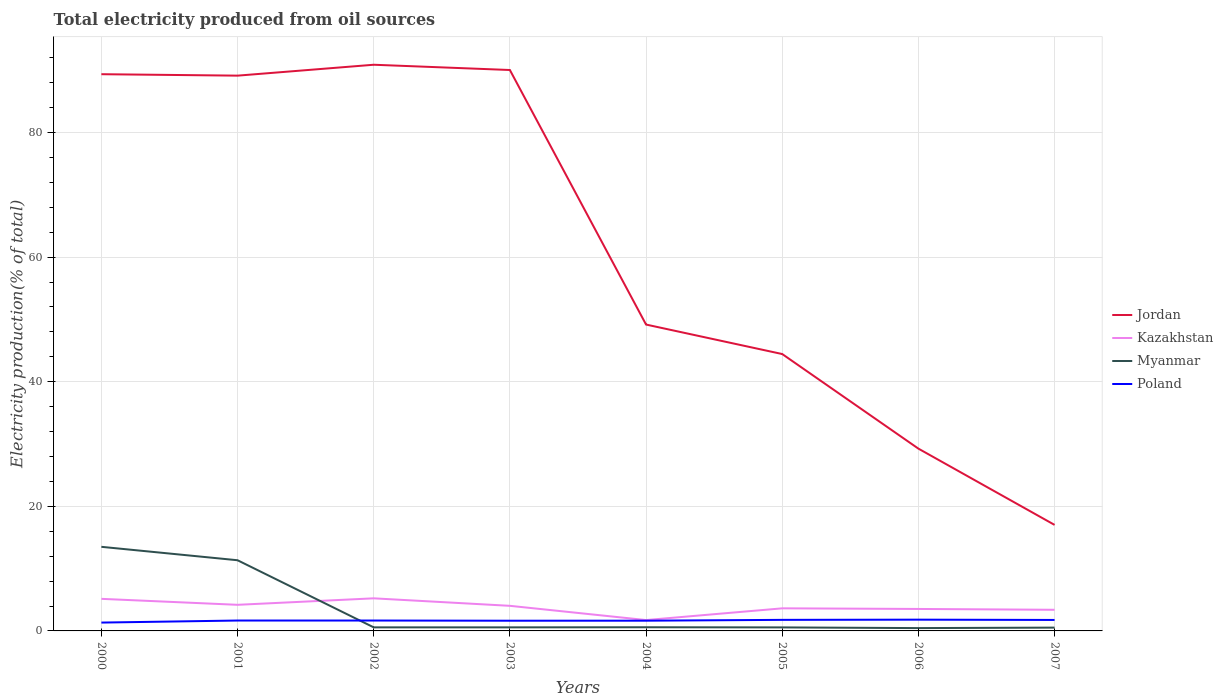Across all years, what is the maximum total electricity produced in Poland?
Provide a succinct answer. 1.34. In which year was the total electricity produced in Myanmar maximum?
Make the answer very short. 2006. What is the total total electricity produced in Kazakhstan in the graph?
Provide a short and direct response. 0.16. What is the difference between the highest and the second highest total electricity produced in Jordan?
Provide a short and direct response. 73.87. How many lines are there?
Offer a very short reply. 4. How many years are there in the graph?
Keep it short and to the point. 8. Does the graph contain any zero values?
Provide a short and direct response. No. Does the graph contain grids?
Give a very brief answer. Yes. How are the legend labels stacked?
Your response must be concise. Vertical. What is the title of the graph?
Offer a terse response. Total electricity produced from oil sources. What is the label or title of the X-axis?
Offer a very short reply. Years. What is the label or title of the Y-axis?
Offer a very short reply. Electricity production(% of total). What is the Electricity production(% of total) of Jordan in 2000?
Keep it short and to the point. 89.37. What is the Electricity production(% of total) of Kazakhstan in 2000?
Offer a very short reply. 5.15. What is the Electricity production(% of total) in Myanmar in 2000?
Offer a very short reply. 13.5. What is the Electricity production(% of total) in Poland in 2000?
Make the answer very short. 1.34. What is the Electricity production(% of total) of Jordan in 2001?
Your answer should be very brief. 89.14. What is the Electricity production(% of total) of Kazakhstan in 2001?
Provide a short and direct response. 4.19. What is the Electricity production(% of total) of Myanmar in 2001?
Offer a very short reply. 11.35. What is the Electricity production(% of total) of Poland in 2001?
Offer a terse response. 1.67. What is the Electricity production(% of total) in Jordan in 2002?
Make the answer very short. 90.89. What is the Electricity production(% of total) in Kazakhstan in 2002?
Keep it short and to the point. 5.23. What is the Electricity production(% of total) of Myanmar in 2002?
Offer a very short reply. 0.57. What is the Electricity production(% of total) in Poland in 2002?
Make the answer very short. 1.67. What is the Electricity production(% of total) of Jordan in 2003?
Your answer should be compact. 90.04. What is the Electricity production(% of total) in Kazakhstan in 2003?
Provide a succinct answer. 4.03. What is the Electricity production(% of total) in Myanmar in 2003?
Your response must be concise. 0.57. What is the Electricity production(% of total) of Poland in 2003?
Ensure brevity in your answer.  1.64. What is the Electricity production(% of total) of Jordan in 2004?
Offer a very short reply. 49.18. What is the Electricity production(% of total) in Kazakhstan in 2004?
Keep it short and to the point. 1.74. What is the Electricity production(% of total) in Myanmar in 2004?
Your response must be concise. 0.59. What is the Electricity production(% of total) of Poland in 2004?
Provide a succinct answer. 1.64. What is the Electricity production(% of total) of Jordan in 2005?
Your answer should be compact. 44.45. What is the Electricity production(% of total) of Kazakhstan in 2005?
Make the answer very short. 3.63. What is the Electricity production(% of total) of Myanmar in 2005?
Ensure brevity in your answer.  0.57. What is the Electricity production(% of total) in Poland in 2005?
Offer a very short reply. 1.77. What is the Electricity production(% of total) in Jordan in 2006?
Provide a short and direct response. 29.26. What is the Electricity production(% of total) of Kazakhstan in 2006?
Your response must be concise. 3.53. What is the Electricity production(% of total) in Myanmar in 2006?
Provide a succinct answer. 0.45. What is the Electricity production(% of total) in Poland in 2006?
Offer a terse response. 1.81. What is the Electricity production(% of total) of Jordan in 2007?
Give a very brief answer. 17.02. What is the Electricity production(% of total) of Kazakhstan in 2007?
Offer a terse response. 3.39. What is the Electricity production(% of total) in Myanmar in 2007?
Keep it short and to the point. 0.53. What is the Electricity production(% of total) in Poland in 2007?
Provide a succinct answer. 1.76. Across all years, what is the maximum Electricity production(% of total) in Jordan?
Your answer should be compact. 90.89. Across all years, what is the maximum Electricity production(% of total) in Kazakhstan?
Keep it short and to the point. 5.23. Across all years, what is the maximum Electricity production(% of total) of Myanmar?
Offer a very short reply. 13.5. Across all years, what is the maximum Electricity production(% of total) of Poland?
Ensure brevity in your answer.  1.81. Across all years, what is the minimum Electricity production(% of total) of Jordan?
Your answer should be very brief. 17.02. Across all years, what is the minimum Electricity production(% of total) of Kazakhstan?
Offer a terse response. 1.74. Across all years, what is the minimum Electricity production(% of total) of Myanmar?
Offer a terse response. 0.45. Across all years, what is the minimum Electricity production(% of total) in Poland?
Provide a succinct answer. 1.34. What is the total Electricity production(% of total) in Jordan in the graph?
Make the answer very short. 499.35. What is the total Electricity production(% of total) in Kazakhstan in the graph?
Give a very brief answer. 30.89. What is the total Electricity production(% of total) of Myanmar in the graph?
Your answer should be very brief. 28.13. What is the total Electricity production(% of total) in Poland in the graph?
Offer a terse response. 13.3. What is the difference between the Electricity production(% of total) in Jordan in 2000 and that in 2001?
Provide a short and direct response. 0.23. What is the difference between the Electricity production(% of total) of Kazakhstan in 2000 and that in 2001?
Make the answer very short. 0.96. What is the difference between the Electricity production(% of total) in Myanmar in 2000 and that in 2001?
Offer a very short reply. 2.16. What is the difference between the Electricity production(% of total) in Poland in 2000 and that in 2001?
Your answer should be very brief. -0.33. What is the difference between the Electricity production(% of total) in Jordan in 2000 and that in 2002?
Offer a terse response. -1.52. What is the difference between the Electricity production(% of total) in Kazakhstan in 2000 and that in 2002?
Ensure brevity in your answer.  -0.08. What is the difference between the Electricity production(% of total) in Myanmar in 2000 and that in 2002?
Give a very brief answer. 12.93. What is the difference between the Electricity production(% of total) of Poland in 2000 and that in 2002?
Ensure brevity in your answer.  -0.33. What is the difference between the Electricity production(% of total) of Jordan in 2000 and that in 2003?
Offer a very short reply. -0.67. What is the difference between the Electricity production(% of total) in Kazakhstan in 2000 and that in 2003?
Ensure brevity in your answer.  1.12. What is the difference between the Electricity production(% of total) of Myanmar in 2000 and that in 2003?
Provide a short and direct response. 12.93. What is the difference between the Electricity production(% of total) of Poland in 2000 and that in 2003?
Your answer should be compact. -0.3. What is the difference between the Electricity production(% of total) in Jordan in 2000 and that in 2004?
Make the answer very short. 40.19. What is the difference between the Electricity production(% of total) in Kazakhstan in 2000 and that in 2004?
Make the answer very short. 3.41. What is the difference between the Electricity production(% of total) of Myanmar in 2000 and that in 2004?
Make the answer very short. 12.91. What is the difference between the Electricity production(% of total) in Poland in 2000 and that in 2004?
Provide a short and direct response. -0.31. What is the difference between the Electricity production(% of total) in Jordan in 2000 and that in 2005?
Ensure brevity in your answer.  44.92. What is the difference between the Electricity production(% of total) in Kazakhstan in 2000 and that in 2005?
Your response must be concise. 1.52. What is the difference between the Electricity production(% of total) of Myanmar in 2000 and that in 2005?
Give a very brief answer. 12.94. What is the difference between the Electricity production(% of total) of Poland in 2000 and that in 2005?
Offer a terse response. -0.44. What is the difference between the Electricity production(% of total) in Jordan in 2000 and that in 2006?
Give a very brief answer. 60.11. What is the difference between the Electricity production(% of total) of Kazakhstan in 2000 and that in 2006?
Ensure brevity in your answer.  1.62. What is the difference between the Electricity production(% of total) of Myanmar in 2000 and that in 2006?
Your response must be concise. 13.05. What is the difference between the Electricity production(% of total) of Poland in 2000 and that in 2006?
Ensure brevity in your answer.  -0.47. What is the difference between the Electricity production(% of total) in Jordan in 2000 and that in 2007?
Keep it short and to the point. 72.35. What is the difference between the Electricity production(% of total) in Kazakhstan in 2000 and that in 2007?
Ensure brevity in your answer.  1.76. What is the difference between the Electricity production(% of total) of Myanmar in 2000 and that in 2007?
Your answer should be compact. 12.97. What is the difference between the Electricity production(% of total) in Poland in 2000 and that in 2007?
Give a very brief answer. -0.42. What is the difference between the Electricity production(% of total) of Jordan in 2001 and that in 2002?
Offer a very short reply. -1.75. What is the difference between the Electricity production(% of total) in Kazakhstan in 2001 and that in 2002?
Provide a short and direct response. -1.04. What is the difference between the Electricity production(% of total) of Myanmar in 2001 and that in 2002?
Offer a very short reply. 10.77. What is the difference between the Electricity production(% of total) of Poland in 2001 and that in 2002?
Your answer should be compact. 0. What is the difference between the Electricity production(% of total) in Jordan in 2001 and that in 2003?
Make the answer very short. -0.9. What is the difference between the Electricity production(% of total) of Kazakhstan in 2001 and that in 2003?
Your answer should be compact. 0.16. What is the difference between the Electricity production(% of total) in Myanmar in 2001 and that in 2003?
Offer a very short reply. 10.77. What is the difference between the Electricity production(% of total) of Poland in 2001 and that in 2003?
Keep it short and to the point. 0.03. What is the difference between the Electricity production(% of total) in Jordan in 2001 and that in 2004?
Offer a very short reply. 39.96. What is the difference between the Electricity production(% of total) of Kazakhstan in 2001 and that in 2004?
Provide a succinct answer. 2.45. What is the difference between the Electricity production(% of total) in Myanmar in 2001 and that in 2004?
Your answer should be very brief. 10.76. What is the difference between the Electricity production(% of total) of Poland in 2001 and that in 2004?
Your answer should be compact. 0.03. What is the difference between the Electricity production(% of total) of Jordan in 2001 and that in 2005?
Make the answer very short. 44.69. What is the difference between the Electricity production(% of total) of Kazakhstan in 2001 and that in 2005?
Keep it short and to the point. 0.57. What is the difference between the Electricity production(% of total) in Myanmar in 2001 and that in 2005?
Your answer should be very brief. 10.78. What is the difference between the Electricity production(% of total) in Poland in 2001 and that in 2005?
Make the answer very short. -0.11. What is the difference between the Electricity production(% of total) of Jordan in 2001 and that in 2006?
Ensure brevity in your answer.  59.88. What is the difference between the Electricity production(% of total) in Kazakhstan in 2001 and that in 2006?
Provide a succinct answer. 0.66. What is the difference between the Electricity production(% of total) in Myanmar in 2001 and that in 2006?
Offer a very short reply. 10.89. What is the difference between the Electricity production(% of total) in Poland in 2001 and that in 2006?
Ensure brevity in your answer.  -0.14. What is the difference between the Electricity production(% of total) of Jordan in 2001 and that in 2007?
Your answer should be very brief. 72.12. What is the difference between the Electricity production(% of total) of Kazakhstan in 2001 and that in 2007?
Provide a succinct answer. 0.8. What is the difference between the Electricity production(% of total) in Myanmar in 2001 and that in 2007?
Provide a short and direct response. 10.81. What is the difference between the Electricity production(% of total) of Poland in 2001 and that in 2007?
Provide a succinct answer. -0.09. What is the difference between the Electricity production(% of total) in Jordan in 2002 and that in 2003?
Give a very brief answer. 0.85. What is the difference between the Electricity production(% of total) in Kazakhstan in 2002 and that in 2003?
Make the answer very short. 1.2. What is the difference between the Electricity production(% of total) of Myanmar in 2002 and that in 2003?
Give a very brief answer. 0. What is the difference between the Electricity production(% of total) in Poland in 2002 and that in 2003?
Your answer should be very brief. 0.03. What is the difference between the Electricity production(% of total) in Jordan in 2002 and that in 2004?
Ensure brevity in your answer.  41.71. What is the difference between the Electricity production(% of total) in Kazakhstan in 2002 and that in 2004?
Ensure brevity in your answer.  3.49. What is the difference between the Electricity production(% of total) of Myanmar in 2002 and that in 2004?
Keep it short and to the point. -0.02. What is the difference between the Electricity production(% of total) in Poland in 2002 and that in 2004?
Your response must be concise. 0.02. What is the difference between the Electricity production(% of total) of Jordan in 2002 and that in 2005?
Your answer should be compact. 46.44. What is the difference between the Electricity production(% of total) in Kazakhstan in 2002 and that in 2005?
Make the answer very short. 1.61. What is the difference between the Electricity production(% of total) of Myanmar in 2002 and that in 2005?
Your response must be concise. 0.01. What is the difference between the Electricity production(% of total) in Poland in 2002 and that in 2005?
Ensure brevity in your answer.  -0.11. What is the difference between the Electricity production(% of total) in Jordan in 2002 and that in 2006?
Your response must be concise. 61.63. What is the difference between the Electricity production(% of total) in Kazakhstan in 2002 and that in 2006?
Offer a very short reply. 1.71. What is the difference between the Electricity production(% of total) of Myanmar in 2002 and that in 2006?
Offer a very short reply. 0.12. What is the difference between the Electricity production(% of total) in Poland in 2002 and that in 2006?
Keep it short and to the point. -0.14. What is the difference between the Electricity production(% of total) in Jordan in 2002 and that in 2007?
Give a very brief answer. 73.87. What is the difference between the Electricity production(% of total) of Kazakhstan in 2002 and that in 2007?
Your response must be concise. 1.84. What is the difference between the Electricity production(% of total) of Myanmar in 2002 and that in 2007?
Give a very brief answer. 0.04. What is the difference between the Electricity production(% of total) in Poland in 2002 and that in 2007?
Provide a short and direct response. -0.09. What is the difference between the Electricity production(% of total) of Jordan in 2003 and that in 2004?
Keep it short and to the point. 40.86. What is the difference between the Electricity production(% of total) of Kazakhstan in 2003 and that in 2004?
Your response must be concise. 2.29. What is the difference between the Electricity production(% of total) of Myanmar in 2003 and that in 2004?
Your answer should be compact. -0.02. What is the difference between the Electricity production(% of total) of Poland in 2003 and that in 2004?
Keep it short and to the point. -0.01. What is the difference between the Electricity production(% of total) of Jordan in 2003 and that in 2005?
Provide a succinct answer. 45.59. What is the difference between the Electricity production(% of total) in Kazakhstan in 2003 and that in 2005?
Your response must be concise. 0.4. What is the difference between the Electricity production(% of total) of Myanmar in 2003 and that in 2005?
Your answer should be compact. 0.01. What is the difference between the Electricity production(% of total) of Poland in 2003 and that in 2005?
Make the answer very short. -0.14. What is the difference between the Electricity production(% of total) of Jordan in 2003 and that in 2006?
Ensure brevity in your answer.  60.78. What is the difference between the Electricity production(% of total) of Kazakhstan in 2003 and that in 2006?
Keep it short and to the point. 0.5. What is the difference between the Electricity production(% of total) in Myanmar in 2003 and that in 2006?
Make the answer very short. 0.12. What is the difference between the Electricity production(% of total) in Poland in 2003 and that in 2006?
Your response must be concise. -0.17. What is the difference between the Electricity production(% of total) in Jordan in 2003 and that in 2007?
Make the answer very short. 73.02. What is the difference between the Electricity production(% of total) in Kazakhstan in 2003 and that in 2007?
Provide a short and direct response. 0.63. What is the difference between the Electricity production(% of total) in Myanmar in 2003 and that in 2007?
Your answer should be compact. 0.04. What is the difference between the Electricity production(% of total) in Poland in 2003 and that in 2007?
Offer a terse response. -0.12. What is the difference between the Electricity production(% of total) of Jordan in 2004 and that in 2005?
Provide a succinct answer. 4.73. What is the difference between the Electricity production(% of total) of Kazakhstan in 2004 and that in 2005?
Provide a short and direct response. -1.88. What is the difference between the Electricity production(% of total) in Myanmar in 2004 and that in 2005?
Your answer should be very brief. 0.02. What is the difference between the Electricity production(% of total) of Poland in 2004 and that in 2005?
Make the answer very short. -0.13. What is the difference between the Electricity production(% of total) in Jordan in 2004 and that in 2006?
Offer a terse response. 19.92. What is the difference between the Electricity production(% of total) of Kazakhstan in 2004 and that in 2006?
Provide a short and direct response. -1.78. What is the difference between the Electricity production(% of total) of Myanmar in 2004 and that in 2006?
Your response must be concise. 0.13. What is the difference between the Electricity production(% of total) of Poland in 2004 and that in 2006?
Your response must be concise. -0.17. What is the difference between the Electricity production(% of total) in Jordan in 2004 and that in 2007?
Your answer should be very brief. 32.16. What is the difference between the Electricity production(% of total) in Kazakhstan in 2004 and that in 2007?
Offer a terse response. -1.65. What is the difference between the Electricity production(% of total) in Myanmar in 2004 and that in 2007?
Your answer should be very brief. 0.06. What is the difference between the Electricity production(% of total) in Poland in 2004 and that in 2007?
Offer a terse response. -0.12. What is the difference between the Electricity production(% of total) of Jordan in 2005 and that in 2006?
Keep it short and to the point. 15.19. What is the difference between the Electricity production(% of total) in Kazakhstan in 2005 and that in 2006?
Your response must be concise. 0.1. What is the difference between the Electricity production(% of total) in Myanmar in 2005 and that in 2006?
Ensure brevity in your answer.  0.11. What is the difference between the Electricity production(% of total) in Poland in 2005 and that in 2006?
Provide a short and direct response. -0.03. What is the difference between the Electricity production(% of total) in Jordan in 2005 and that in 2007?
Your answer should be very brief. 27.43. What is the difference between the Electricity production(% of total) of Kazakhstan in 2005 and that in 2007?
Make the answer very short. 0.23. What is the difference between the Electricity production(% of total) of Myanmar in 2005 and that in 2007?
Offer a terse response. 0.03. What is the difference between the Electricity production(% of total) in Poland in 2005 and that in 2007?
Make the answer very short. 0.01. What is the difference between the Electricity production(% of total) in Jordan in 2006 and that in 2007?
Give a very brief answer. 12.24. What is the difference between the Electricity production(% of total) in Kazakhstan in 2006 and that in 2007?
Your response must be concise. 0.13. What is the difference between the Electricity production(% of total) in Myanmar in 2006 and that in 2007?
Your answer should be compact. -0.08. What is the difference between the Electricity production(% of total) in Poland in 2006 and that in 2007?
Provide a succinct answer. 0.05. What is the difference between the Electricity production(% of total) in Jordan in 2000 and the Electricity production(% of total) in Kazakhstan in 2001?
Your response must be concise. 85.18. What is the difference between the Electricity production(% of total) of Jordan in 2000 and the Electricity production(% of total) of Myanmar in 2001?
Give a very brief answer. 78.02. What is the difference between the Electricity production(% of total) in Jordan in 2000 and the Electricity production(% of total) in Poland in 2001?
Your answer should be very brief. 87.7. What is the difference between the Electricity production(% of total) in Kazakhstan in 2000 and the Electricity production(% of total) in Myanmar in 2001?
Provide a succinct answer. -6.2. What is the difference between the Electricity production(% of total) of Kazakhstan in 2000 and the Electricity production(% of total) of Poland in 2001?
Offer a very short reply. 3.48. What is the difference between the Electricity production(% of total) of Myanmar in 2000 and the Electricity production(% of total) of Poland in 2001?
Provide a succinct answer. 11.83. What is the difference between the Electricity production(% of total) in Jordan in 2000 and the Electricity production(% of total) in Kazakhstan in 2002?
Your response must be concise. 84.14. What is the difference between the Electricity production(% of total) in Jordan in 2000 and the Electricity production(% of total) in Myanmar in 2002?
Offer a very short reply. 88.8. What is the difference between the Electricity production(% of total) in Jordan in 2000 and the Electricity production(% of total) in Poland in 2002?
Provide a succinct answer. 87.7. What is the difference between the Electricity production(% of total) of Kazakhstan in 2000 and the Electricity production(% of total) of Myanmar in 2002?
Offer a very short reply. 4.58. What is the difference between the Electricity production(% of total) of Kazakhstan in 2000 and the Electricity production(% of total) of Poland in 2002?
Make the answer very short. 3.48. What is the difference between the Electricity production(% of total) in Myanmar in 2000 and the Electricity production(% of total) in Poland in 2002?
Keep it short and to the point. 11.83. What is the difference between the Electricity production(% of total) in Jordan in 2000 and the Electricity production(% of total) in Kazakhstan in 2003?
Make the answer very short. 85.34. What is the difference between the Electricity production(% of total) of Jordan in 2000 and the Electricity production(% of total) of Myanmar in 2003?
Keep it short and to the point. 88.8. What is the difference between the Electricity production(% of total) in Jordan in 2000 and the Electricity production(% of total) in Poland in 2003?
Make the answer very short. 87.73. What is the difference between the Electricity production(% of total) of Kazakhstan in 2000 and the Electricity production(% of total) of Myanmar in 2003?
Offer a terse response. 4.58. What is the difference between the Electricity production(% of total) in Kazakhstan in 2000 and the Electricity production(% of total) in Poland in 2003?
Keep it short and to the point. 3.51. What is the difference between the Electricity production(% of total) in Myanmar in 2000 and the Electricity production(% of total) in Poland in 2003?
Your answer should be compact. 11.86. What is the difference between the Electricity production(% of total) of Jordan in 2000 and the Electricity production(% of total) of Kazakhstan in 2004?
Ensure brevity in your answer.  87.63. What is the difference between the Electricity production(% of total) of Jordan in 2000 and the Electricity production(% of total) of Myanmar in 2004?
Ensure brevity in your answer.  88.78. What is the difference between the Electricity production(% of total) of Jordan in 2000 and the Electricity production(% of total) of Poland in 2004?
Provide a short and direct response. 87.73. What is the difference between the Electricity production(% of total) of Kazakhstan in 2000 and the Electricity production(% of total) of Myanmar in 2004?
Make the answer very short. 4.56. What is the difference between the Electricity production(% of total) of Kazakhstan in 2000 and the Electricity production(% of total) of Poland in 2004?
Give a very brief answer. 3.51. What is the difference between the Electricity production(% of total) of Myanmar in 2000 and the Electricity production(% of total) of Poland in 2004?
Provide a short and direct response. 11.86. What is the difference between the Electricity production(% of total) in Jordan in 2000 and the Electricity production(% of total) in Kazakhstan in 2005?
Give a very brief answer. 85.74. What is the difference between the Electricity production(% of total) in Jordan in 2000 and the Electricity production(% of total) in Myanmar in 2005?
Your answer should be very brief. 88.8. What is the difference between the Electricity production(% of total) in Jordan in 2000 and the Electricity production(% of total) in Poland in 2005?
Your answer should be compact. 87.59. What is the difference between the Electricity production(% of total) of Kazakhstan in 2000 and the Electricity production(% of total) of Myanmar in 2005?
Make the answer very short. 4.58. What is the difference between the Electricity production(% of total) of Kazakhstan in 2000 and the Electricity production(% of total) of Poland in 2005?
Ensure brevity in your answer.  3.38. What is the difference between the Electricity production(% of total) of Myanmar in 2000 and the Electricity production(% of total) of Poland in 2005?
Make the answer very short. 11.73. What is the difference between the Electricity production(% of total) in Jordan in 2000 and the Electricity production(% of total) in Kazakhstan in 2006?
Your answer should be very brief. 85.84. What is the difference between the Electricity production(% of total) in Jordan in 2000 and the Electricity production(% of total) in Myanmar in 2006?
Give a very brief answer. 88.92. What is the difference between the Electricity production(% of total) in Jordan in 2000 and the Electricity production(% of total) in Poland in 2006?
Your response must be concise. 87.56. What is the difference between the Electricity production(% of total) in Kazakhstan in 2000 and the Electricity production(% of total) in Myanmar in 2006?
Offer a very short reply. 4.7. What is the difference between the Electricity production(% of total) in Kazakhstan in 2000 and the Electricity production(% of total) in Poland in 2006?
Provide a succinct answer. 3.34. What is the difference between the Electricity production(% of total) in Myanmar in 2000 and the Electricity production(% of total) in Poland in 2006?
Ensure brevity in your answer.  11.69. What is the difference between the Electricity production(% of total) in Jordan in 2000 and the Electricity production(% of total) in Kazakhstan in 2007?
Provide a succinct answer. 85.98. What is the difference between the Electricity production(% of total) of Jordan in 2000 and the Electricity production(% of total) of Myanmar in 2007?
Ensure brevity in your answer.  88.84. What is the difference between the Electricity production(% of total) of Jordan in 2000 and the Electricity production(% of total) of Poland in 2007?
Provide a succinct answer. 87.61. What is the difference between the Electricity production(% of total) in Kazakhstan in 2000 and the Electricity production(% of total) in Myanmar in 2007?
Offer a very short reply. 4.62. What is the difference between the Electricity production(% of total) of Kazakhstan in 2000 and the Electricity production(% of total) of Poland in 2007?
Provide a short and direct response. 3.39. What is the difference between the Electricity production(% of total) of Myanmar in 2000 and the Electricity production(% of total) of Poland in 2007?
Provide a short and direct response. 11.74. What is the difference between the Electricity production(% of total) of Jordan in 2001 and the Electricity production(% of total) of Kazakhstan in 2002?
Keep it short and to the point. 83.9. What is the difference between the Electricity production(% of total) of Jordan in 2001 and the Electricity production(% of total) of Myanmar in 2002?
Give a very brief answer. 88.57. What is the difference between the Electricity production(% of total) of Jordan in 2001 and the Electricity production(% of total) of Poland in 2002?
Give a very brief answer. 87.47. What is the difference between the Electricity production(% of total) of Kazakhstan in 2001 and the Electricity production(% of total) of Myanmar in 2002?
Your answer should be compact. 3.62. What is the difference between the Electricity production(% of total) of Kazakhstan in 2001 and the Electricity production(% of total) of Poland in 2002?
Give a very brief answer. 2.52. What is the difference between the Electricity production(% of total) of Myanmar in 2001 and the Electricity production(% of total) of Poland in 2002?
Give a very brief answer. 9.68. What is the difference between the Electricity production(% of total) of Jordan in 2001 and the Electricity production(% of total) of Kazakhstan in 2003?
Give a very brief answer. 85.11. What is the difference between the Electricity production(% of total) in Jordan in 2001 and the Electricity production(% of total) in Myanmar in 2003?
Make the answer very short. 88.57. What is the difference between the Electricity production(% of total) of Jordan in 2001 and the Electricity production(% of total) of Poland in 2003?
Your answer should be compact. 87.5. What is the difference between the Electricity production(% of total) of Kazakhstan in 2001 and the Electricity production(% of total) of Myanmar in 2003?
Your answer should be very brief. 3.62. What is the difference between the Electricity production(% of total) in Kazakhstan in 2001 and the Electricity production(% of total) in Poland in 2003?
Provide a succinct answer. 2.55. What is the difference between the Electricity production(% of total) of Myanmar in 2001 and the Electricity production(% of total) of Poland in 2003?
Provide a short and direct response. 9.71. What is the difference between the Electricity production(% of total) in Jordan in 2001 and the Electricity production(% of total) in Kazakhstan in 2004?
Provide a succinct answer. 87.39. What is the difference between the Electricity production(% of total) of Jordan in 2001 and the Electricity production(% of total) of Myanmar in 2004?
Provide a succinct answer. 88.55. What is the difference between the Electricity production(% of total) in Jordan in 2001 and the Electricity production(% of total) in Poland in 2004?
Ensure brevity in your answer.  87.49. What is the difference between the Electricity production(% of total) of Kazakhstan in 2001 and the Electricity production(% of total) of Myanmar in 2004?
Provide a succinct answer. 3.6. What is the difference between the Electricity production(% of total) in Kazakhstan in 2001 and the Electricity production(% of total) in Poland in 2004?
Your answer should be very brief. 2.55. What is the difference between the Electricity production(% of total) in Myanmar in 2001 and the Electricity production(% of total) in Poland in 2004?
Offer a very short reply. 9.7. What is the difference between the Electricity production(% of total) of Jordan in 2001 and the Electricity production(% of total) of Kazakhstan in 2005?
Offer a terse response. 85.51. What is the difference between the Electricity production(% of total) of Jordan in 2001 and the Electricity production(% of total) of Myanmar in 2005?
Offer a terse response. 88.57. What is the difference between the Electricity production(% of total) of Jordan in 2001 and the Electricity production(% of total) of Poland in 2005?
Provide a succinct answer. 87.36. What is the difference between the Electricity production(% of total) in Kazakhstan in 2001 and the Electricity production(% of total) in Myanmar in 2005?
Offer a terse response. 3.63. What is the difference between the Electricity production(% of total) in Kazakhstan in 2001 and the Electricity production(% of total) in Poland in 2005?
Ensure brevity in your answer.  2.42. What is the difference between the Electricity production(% of total) of Myanmar in 2001 and the Electricity production(% of total) of Poland in 2005?
Make the answer very short. 9.57. What is the difference between the Electricity production(% of total) in Jordan in 2001 and the Electricity production(% of total) in Kazakhstan in 2006?
Ensure brevity in your answer.  85.61. What is the difference between the Electricity production(% of total) in Jordan in 2001 and the Electricity production(% of total) in Myanmar in 2006?
Give a very brief answer. 88.68. What is the difference between the Electricity production(% of total) in Jordan in 2001 and the Electricity production(% of total) in Poland in 2006?
Make the answer very short. 87.33. What is the difference between the Electricity production(% of total) of Kazakhstan in 2001 and the Electricity production(% of total) of Myanmar in 2006?
Provide a succinct answer. 3.74. What is the difference between the Electricity production(% of total) in Kazakhstan in 2001 and the Electricity production(% of total) in Poland in 2006?
Keep it short and to the point. 2.38. What is the difference between the Electricity production(% of total) in Myanmar in 2001 and the Electricity production(% of total) in Poland in 2006?
Your answer should be very brief. 9.54. What is the difference between the Electricity production(% of total) of Jordan in 2001 and the Electricity production(% of total) of Kazakhstan in 2007?
Your answer should be compact. 85.74. What is the difference between the Electricity production(% of total) in Jordan in 2001 and the Electricity production(% of total) in Myanmar in 2007?
Ensure brevity in your answer.  88.61. What is the difference between the Electricity production(% of total) of Jordan in 2001 and the Electricity production(% of total) of Poland in 2007?
Make the answer very short. 87.38. What is the difference between the Electricity production(% of total) in Kazakhstan in 2001 and the Electricity production(% of total) in Myanmar in 2007?
Offer a terse response. 3.66. What is the difference between the Electricity production(% of total) of Kazakhstan in 2001 and the Electricity production(% of total) of Poland in 2007?
Ensure brevity in your answer.  2.43. What is the difference between the Electricity production(% of total) of Myanmar in 2001 and the Electricity production(% of total) of Poland in 2007?
Offer a very short reply. 9.59. What is the difference between the Electricity production(% of total) in Jordan in 2002 and the Electricity production(% of total) in Kazakhstan in 2003?
Offer a terse response. 86.86. What is the difference between the Electricity production(% of total) in Jordan in 2002 and the Electricity production(% of total) in Myanmar in 2003?
Your answer should be compact. 90.32. What is the difference between the Electricity production(% of total) of Jordan in 2002 and the Electricity production(% of total) of Poland in 2003?
Your answer should be compact. 89.25. What is the difference between the Electricity production(% of total) of Kazakhstan in 2002 and the Electricity production(% of total) of Myanmar in 2003?
Offer a very short reply. 4.66. What is the difference between the Electricity production(% of total) in Kazakhstan in 2002 and the Electricity production(% of total) in Poland in 2003?
Ensure brevity in your answer.  3.6. What is the difference between the Electricity production(% of total) of Myanmar in 2002 and the Electricity production(% of total) of Poland in 2003?
Keep it short and to the point. -1.06. What is the difference between the Electricity production(% of total) in Jordan in 2002 and the Electricity production(% of total) in Kazakhstan in 2004?
Keep it short and to the point. 89.14. What is the difference between the Electricity production(% of total) in Jordan in 2002 and the Electricity production(% of total) in Myanmar in 2004?
Provide a short and direct response. 90.3. What is the difference between the Electricity production(% of total) of Jordan in 2002 and the Electricity production(% of total) of Poland in 2004?
Offer a terse response. 89.24. What is the difference between the Electricity production(% of total) of Kazakhstan in 2002 and the Electricity production(% of total) of Myanmar in 2004?
Make the answer very short. 4.64. What is the difference between the Electricity production(% of total) of Kazakhstan in 2002 and the Electricity production(% of total) of Poland in 2004?
Provide a short and direct response. 3.59. What is the difference between the Electricity production(% of total) of Myanmar in 2002 and the Electricity production(% of total) of Poland in 2004?
Provide a short and direct response. -1.07. What is the difference between the Electricity production(% of total) of Jordan in 2002 and the Electricity production(% of total) of Kazakhstan in 2005?
Your answer should be very brief. 87.26. What is the difference between the Electricity production(% of total) of Jordan in 2002 and the Electricity production(% of total) of Myanmar in 2005?
Make the answer very short. 90.32. What is the difference between the Electricity production(% of total) of Jordan in 2002 and the Electricity production(% of total) of Poland in 2005?
Make the answer very short. 89.11. What is the difference between the Electricity production(% of total) in Kazakhstan in 2002 and the Electricity production(% of total) in Myanmar in 2005?
Provide a succinct answer. 4.67. What is the difference between the Electricity production(% of total) in Kazakhstan in 2002 and the Electricity production(% of total) in Poland in 2005?
Ensure brevity in your answer.  3.46. What is the difference between the Electricity production(% of total) in Myanmar in 2002 and the Electricity production(% of total) in Poland in 2005?
Give a very brief answer. -1.2. What is the difference between the Electricity production(% of total) in Jordan in 2002 and the Electricity production(% of total) in Kazakhstan in 2006?
Provide a succinct answer. 87.36. What is the difference between the Electricity production(% of total) in Jordan in 2002 and the Electricity production(% of total) in Myanmar in 2006?
Make the answer very short. 90.43. What is the difference between the Electricity production(% of total) in Jordan in 2002 and the Electricity production(% of total) in Poland in 2006?
Offer a terse response. 89.08. What is the difference between the Electricity production(% of total) in Kazakhstan in 2002 and the Electricity production(% of total) in Myanmar in 2006?
Your answer should be very brief. 4.78. What is the difference between the Electricity production(% of total) in Kazakhstan in 2002 and the Electricity production(% of total) in Poland in 2006?
Give a very brief answer. 3.42. What is the difference between the Electricity production(% of total) of Myanmar in 2002 and the Electricity production(% of total) of Poland in 2006?
Provide a short and direct response. -1.24. What is the difference between the Electricity production(% of total) in Jordan in 2002 and the Electricity production(% of total) in Kazakhstan in 2007?
Your answer should be compact. 87.49. What is the difference between the Electricity production(% of total) in Jordan in 2002 and the Electricity production(% of total) in Myanmar in 2007?
Your answer should be compact. 90.36. What is the difference between the Electricity production(% of total) in Jordan in 2002 and the Electricity production(% of total) in Poland in 2007?
Provide a succinct answer. 89.13. What is the difference between the Electricity production(% of total) of Kazakhstan in 2002 and the Electricity production(% of total) of Myanmar in 2007?
Make the answer very short. 4.7. What is the difference between the Electricity production(% of total) of Kazakhstan in 2002 and the Electricity production(% of total) of Poland in 2007?
Provide a succinct answer. 3.47. What is the difference between the Electricity production(% of total) of Myanmar in 2002 and the Electricity production(% of total) of Poland in 2007?
Your answer should be very brief. -1.19. What is the difference between the Electricity production(% of total) in Jordan in 2003 and the Electricity production(% of total) in Kazakhstan in 2004?
Your answer should be very brief. 88.3. What is the difference between the Electricity production(% of total) in Jordan in 2003 and the Electricity production(% of total) in Myanmar in 2004?
Offer a very short reply. 89.45. What is the difference between the Electricity production(% of total) of Jordan in 2003 and the Electricity production(% of total) of Poland in 2004?
Your answer should be very brief. 88.4. What is the difference between the Electricity production(% of total) in Kazakhstan in 2003 and the Electricity production(% of total) in Myanmar in 2004?
Make the answer very short. 3.44. What is the difference between the Electricity production(% of total) of Kazakhstan in 2003 and the Electricity production(% of total) of Poland in 2004?
Keep it short and to the point. 2.39. What is the difference between the Electricity production(% of total) in Myanmar in 2003 and the Electricity production(% of total) in Poland in 2004?
Provide a succinct answer. -1.07. What is the difference between the Electricity production(% of total) of Jordan in 2003 and the Electricity production(% of total) of Kazakhstan in 2005?
Provide a succinct answer. 86.42. What is the difference between the Electricity production(% of total) of Jordan in 2003 and the Electricity production(% of total) of Myanmar in 2005?
Provide a succinct answer. 89.48. What is the difference between the Electricity production(% of total) in Jordan in 2003 and the Electricity production(% of total) in Poland in 2005?
Your answer should be compact. 88.27. What is the difference between the Electricity production(% of total) of Kazakhstan in 2003 and the Electricity production(% of total) of Myanmar in 2005?
Offer a very short reply. 3.46. What is the difference between the Electricity production(% of total) in Kazakhstan in 2003 and the Electricity production(% of total) in Poland in 2005?
Provide a short and direct response. 2.25. What is the difference between the Electricity production(% of total) in Myanmar in 2003 and the Electricity production(% of total) in Poland in 2005?
Keep it short and to the point. -1.2. What is the difference between the Electricity production(% of total) in Jordan in 2003 and the Electricity production(% of total) in Kazakhstan in 2006?
Your response must be concise. 86.52. What is the difference between the Electricity production(% of total) in Jordan in 2003 and the Electricity production(% of total) in Myanmar in 2006?
Your response must be concise. 89.59. What is the difference between the Electricity production(% of total) in Jordan in 2003 and the Electricity production(% of total) in Poland in 2006?
Keep it short and to the point. 88.23. What is the difference between the Electricity production(% of total) of Kazakhstan in 2003 and the Electricity production(% of total) of Myanmar in 2006?
Keep it short and to the point. 3.57. What is the difference between the Electricity production(% of total) in Kazakhstan in 2003 and the Electricity production(% of total) in Poland in 2006?
Offer a very short reply. 2.22. What is the difference between the Electricity production(% of total) of Myanmar in 2003 and the Electricity production(% of total) of Poland in 2006?
Ensure brevity in your answer.  -1.24. What is the difference between the Electricity production(% of total) of Jordan in 2003 and the Electricity production(% of total) of Kazakhstan in 2007?
Provide a succinct answer. 86.65. What is the difference between the Electricity production(% of total) in Jordan in 2003 and the Electricity production(% of total) in Myanmar in 2007?
Give a very brief answer. 89.51. What is the difference between the Electricity production(% of total) in Jordan in 2003 and the Electricity production(% of total) in Poland in 2007?
Offer a very short reply. 88.28. What is the difference between the Electricity production(% of total) in Kazakhstan in 2003 and the Electricity production(% of total) in Myanmar in 2007?
Provide a short and direct response. 3.5. What is the difference between the Electricity production(% of total) of Kazakhstan in 2003 and the Electricity production(% of total) of Poland in 2007?
Offer a very short reply. 2.27. What is the difference between the Electricity production(% of total) of Myanmar in 2003 and the Electricity production(% of total) of Poland in 2007?
Keep it short and to the point. -1.19. What is the difference between the Electricity production(% of total) in Jordan in 2004 and the Electricity production(% of total) in Kazakhstan in 2005?
Your answer should be compact. 45.55. What is the difference between the Electricity production(% of total) in Jordan in 2004 and the Electricity production(% of total) in Myanmar in 2005?
Your answer should be compact. 48.62. What is the difference between the Electricity production(% of total) in Jordan in 2004 and the Electricity production(% of total) in Poland in 2005?
Make the answer very short. 47.41. What is the difference between the Electricity production(% of total) of Kazakhstan in 2004 and the Electricity production(% of total) of Myanmar in 2005?
Your answer should be compact. 1.18. What is the difference between the Electricity production(% of total) in Kazakhstan in 2004 and the Electricity production(% of total) in Poland in 2005?
Offer a terse response. -0.03. What is the difference between the Electricity production(% of total) in Myanmar in 2004 and the Electricity production(% of total) in Poland in 2005?
Offer a terse response. -1.19. What is the difference between the Electricity production(% of total) of Jordan in 2004 and the Electricity production(% of total) of Kazakhstan in 2006?
Your answer should be compact. 45.65. What is the difference between the Electricity production(% of total) in Jordan in 2004 and the Electricity production(% of total) in Myanmar in 2006?
Provide a succinct answer. 48.73. What is the difference between the Electricity production(% of total) in Jordan in 2004 and the Electricity production(% of total) in Poland in 2006?
Your answer should be compact. 47.37. What is the difference between the Electricity production(% of total) in Kazakhstan in 2004 and the Electricity production(% of total) in Myanmar in 2006?
Give a very brief answer. 1.29. What is the difference between the Electricity production(% of total) of Kazakhstan in 2004 and the Electricity production(% of total) of Poland in 2006?
Your response must be concise. -0.07. What is the difference between the Electricity production(% of total) of Myanmar in 2004 and the Electricity production(% of total) of Poland in 2006?
Make the answer very short. -1.22. What is the difference between the Electricity production(% of total) of Jordan in 2004 and the Electricity production(% of total) of Kazakhstan in 2007?
Your answer should be very brief. 45.79. What is the difference between the Electricity production(% of total) of Jordan in 2004 and the Electricity production(% of total) of Myanmar in 2007?
Offer a very short reply. 48.65. What is the difference between the Electricity production(% of total) in Jordan in 2004 and the Electricity production(% of total) in Poland in 2007?
Keep it short and to the point. 47.42. What is the difference between the Electricity production(% of total) of Kazakhstan in 2004 and the Electricity production(% of total) of Myanmar in 2007?
Make the answer very short. 1.21. What is the difference between the Electricity production(% of total) in Kazakhstan in 2004 and the Electricity production(% of total) in Poland in 2007?
Ensure brevity in your answer.  -0.02. What is the difference between the Electricity production(% of total) of Myanmar in 2004 and the Electricity production(% of total) of Poland in 2007?
Give a very brief answer. -1.17. What is the difference between the Electricity production(% of total) of Jordan in 2005 and the Electricity production(% of total) of Kazakhstan in 2006?
Your answer should be very brief. 40.92. What is the difference between the Electricity production(% of total) of Jordan in 2005 and the Electricity production(% of total) of Myanmar in 2006?
Offer a terse response. 43.99. What is the difference between the Electricity production(% of total) of Jordan in 2005 and the Electricity production(% of total) of Poland in 2006?
Provide a succinct answer. 42.64. What is the difference between the Electricity production(% of total) of Kazakhstan in 2005 and the Electricity production(% of total) of Myanmar in 2006?
Provide a succinct answer. 3.17. What is the difference between the Electricity production(% of total) of Kazakhstan in 2005 and the Electricity production(% of total) of Poland in 2006?
Your answer should be very brief. 1.82. What is the difference between the Electricity production(% of total) in Myanmar in 2005 and the Electricity production(% of total) in Poland in 2006?
Provide a short and direct response. -1.24. What is the difference between the Electricity production(% of total) in Jordan in 2005 and the Electricity production(% of total) in Kazakhstan in 2007?
Provide a short and direct response. 41.05. What is the difference between the Electricity production(% of total) in Jordan in 2005 and the Electricity production(% of total) in Myanmar in 2007?
Make the answer very short. 43.92. What is the difference between the Electricity production(% of total) in Jordan in 2005 and the Electricity production(% of total) in Poland in 2007?
Ensure brevity in your answer.  42.69. What is the difference between the Electricity production(% of total) of Kazakhstan in 2005 and the Electricity production(% of total) of Myanmar in 2007?
Make the answer very short. 3.09. What is the difference between the Electricity production(% of total) in Kazakhstan in 2005 and the Electricity production(% of total) in Poland in 2007?
Provide a short and direct response. 1.87. What is the difference between the Electricity production(% of total) in Myanmar in 2005 and the Electricity production(% of total) in Poland in 2007?
Your answer should be very brief. -1.19. What is the difference between the Electricity production(% of total) of Jordan in 2006 and the Electricity production(% of total) of Kazakhstan in 2007?
Your response must be concise. 25.87. What is the difference between the Electricity production(% of total) of Jordan in 2006 and the Electricity production(% of total) of Myanmar in 2007?
Offer a terse response. 28.73. What is the difference between the Electricity production(% of total) of Jordan in 2006 and the Electricity production(% of total) of Poland in 2007?
Offer a terse response. 27.5. What is the difference between the Electricity production(% of total) in Kazakhstan in 2006 and the Electricity production(% of total) in Myanmar in 2007?
Ensure brevity in your answer.  3. What is the difference between the Electricity production(% of total) in Kazakhstan in 2006 and the Electricity production(% of total) in Poland in 2007?
Your response must be concise. 1.77. What is the difference between the Electricity production(% of total) of Myanmar in 2006 and the Electricity production(% of total) of Poland in 2007?
Give a very brief answer. -1.31. What is the average Electricity production(% of total) in Jordan per year?
Provide a short and direct response. 62.42. What is the average Electricity production(% of total) of Kazakhstan per year?
Provide a succinct answer. 3.86. What is the average Electricity production(% of total) in Myanmar per year?
Your answer should be compact. 3.52. What is the average Electricity production(% of total) in Poland per year?
Keep it short and to the point. 1.66. In the year 2000, what is the difference between the Electricity production(% of total) in Jordan and Electricity production(% of total) in Kazakhstan?
Ensure brevity in your answer.  84.22. In the year 2000, what is the difference between the Electricity production(% of total) in Jordan and Electricity production(% of total) in Myanmar?
Offer a terse response. 75.87. In the year 2000, what is the difference between the Electricity production(% of total) of Jordan and Electricity production(% of total) of Poland?
Provide a short and direct response. 88.03. In the year 2000, what is the difference between the Electricity production(% of total) of Kazakhstan and Electricity production(% of total) of Myanmar?
Your response must be concise. -8.35. In the year 2000, what is the difference between the Electricity production(% of total) of Kazakhstan and Electricity production(% of total) of Poland?
Ensure brevity in your answer.  3.81. In the year 2000, what is the difference between the Electricity production(% of total) of Myanmar and Electricity production(% of total) of Poland?
Make the answer very short. 12.16. In the year 2001, what is the difference between the Electricity production(% of total) of Jordan and Electricity production(% of total) of Kazakhstan?
Your response must be concise. 84.95. In the year 2001, what is the difference between the Electricity production(% of total) of Jordan and Electricity production(% of total) of Myanmar?
Keep it short and to the point. 77.79. In the year 2001, what is the difference between the Electricity production(% of total) in Jordan and Electricity production(% of total) in Poland?
Offer a terse response. 87.47. In the year 2001, what is the difference between the Electricity production(% of total) of Kazakhstan and Electricity production(% of total) of Myanmar?
Offer a terse response. -7.15. In the year 2001, what is the difference between the Electricity production(% of total) of Kazakhstan and Electricity production(% of total) of Poland?
Keep it short and to the point. 2.52. In the year 2001, what is the difference between the Electricity production(% of total) in Myanmar and Electricity production(% of total) in Poland?
Provide a succinct answer. 9.68. In the year 2002, what is the difference between the Electricity production(% of total) in Jordan and Electricity production(% of total) in Kazakhstan?
Give a very brief answer. 85.65. In the year 2002, what is the difference between the Electricity production(% of total) in Jordan and Electricity production(% of total) in Myanmar?
Offer a terse response. 90.32. In the year 2002, what is the difference between the Electricity production(% of total) in Jordan and Electricity production(% of total) in Poland?
Your answer should be compact. 89.22. In the year 2002, what is the difference between the Electricity production(% of total) in Kazakhstan and Electricity production(% of total) in Myanmar?
Your answer should be very brief. 4.66. In the year 2002, what is the difference between the Electricity production(% of total) of Kazakhstan and Electricity production(% of total) of Poland?
Your response must be concise. 3.57. In the year 2002, what is the difference between the Electricity production(% of total) in Myanmar and Electricity production(% of total) in Poland?
Offer a terse response. -1.1. In the year 2003, what is the difference between the Electricity production(% of total) of Jordan and Electricity production(% of total) of Kazakhstan?
Offer a terse response. 86.01. In the year 2003, what is the difference between the Electricity production(% of total) of Jordan and Electricity production(% of total) of Myanmar?
Your answer should be very brief. 89.47. In the year 2003, what is the difference between the Electricity production(% of total) of Jordan and Electricity production(% of total) of Poland?
Your answer should be compact. 88.41. In the year 2003, what is the difference between the Electricity production(% of total) in Kazakhstan and Electricity production(% of total) in Myanmar?
Offer a terse response. 3.46. In the year 2003, what is the difference between the Electricity production(% of total) of Kazakhstan and Electricity production(% of total) of Poland?
Make the answer very short. 2.39. In the year 2003, what is the difference between the Electricity production(% of total) of Myanmar and Electricity production(% of total) of Poland?
Offer a very short reply. -1.07. In the year 2004, what is the difference between the Electricity production(% of total) in Jordan and Electricity production(% of total) in Kazakhstan?
Provide a short and direct response. 47.44. In the year 2004, what is the difference between the Electricity production(% of total) of Jordan and Electricity production(% of total) of Myanmar?
Make the answer very short. 48.59. In the year 2004, what is the difference between the Electricity production(% of total) in Jordan and Electricity production(% of total) in Poland?
Keep it short and to the point. 47.54. In the year 2004, what is the difference between the Electricity production(% of total) of Kazakhstan and Electricity production(% of total) of Myanmar?
Offer a very short reply. 1.15. In the year 2004, what is the difference between the Electricity production(% of total) of Kazakhstan and Electricity production(% of total) of Poland?
Keep it short and to the point. 0.1. In the year 2004, what is the difference between the Electricity production(% of total) of Myanmar and Electricity production(% of total) of Poland?
Your response must be concise. -1.06. In the year 2005, what is the difference between the Electricity production(% of total) in Jordan and Electricity production(% of total) in Kazakhstan?
Offer a very short reply. 40.82. In the year 2005, what is the difference between the Electricity production(% of total) of Jordan and Electricity production(% of total) of Myanmar?
Offer a very short reply. 43.88. In the year 2005, what is the difference between the Electricity production(% of total) of Jordan and Electricity production(% of total) of Poland?
Give a very brief answer. 42.67. In the year 2005, what is the difference between the Electricity production(% of total) in Kazakhstan and Electricity production(% of total) in Myanmar?
Make the answer very short. 3.06. In the year 2005, what is the difference between the Electricity production(% of total) of Kazakhstan and Electricity production(% of total) of Poland?
Your response must be concise. 1.85. In the year 2005, what is the difference between the Electricity production(% of total) of Myanmar and Electricity production(% of total) of Poland?
Offer a terse response. -1.21. In the year 2006, what is the difference between the Electricity production(% of total) of Jordan and Electricity production(% of total) of Kazakhstan?
Offer a terse response. 25.74. In the year 2006, what is the difference between the Electricity production(% of total) of Jordan and Electricity production(% of total) of Myanmar?
Your answer should be compact. 28.81. In the year 2006, what is the difference between the Electricity production(% of total) of Jordan and Electricity production(% of total) of Poland?
Give a very brief answer. 27.45. In the year 2006, what is the difference between the Electricity production(% of total) in Kazakhstan and Electricity production(% of total) in Myanmar?
Offer a very short reply. 3.07. In the year 2006, what is the difference between the Electricity production(% of total) in Kazakhstan and Electricity production(% of total) in Poland?
Give a very brief answer. 1.72. In the year 2006, what is the difference between the Electricity production(% of total) of Myanmar and Electricity production(% of total) of Poland?
Your answer should be compact. -1.36. In the year 2007, what is the difference between the Electricity production(% of total) in Jordan and Electricity production(% of total) in Kazakhstan?
Give a very brief answer. 13.63. In the year 2007, what is the difference between the Electricity production(% of total) in Jordan and Electricity production(% of total) in Myanmar?
Your answer should be very brief. 16.49. In the year 2007, what is the difference between the Electricity production(% of total) in Jordan and Electricity production(% of total) in Poland?
Your answer should be compact. 15.26. In the year 2007, what is the difference between the Electricity production(% of total) in Kazakhstan and Electricity production(% of total) in Myanmar?
Your answer should be very brief. 2.86. In the year 2007, what is the difference between the Electricity production(% of total) in Kazakhstan and Electricity production(% of total) in Poland?
Your answer should be very brief. 1.63. In the year 2007, what is the difference between the Electricity production(% of total) of Myanmar and Electricity production(% of total) of Poland?
Provide a short and direct response. -1.23. What is the ratio of the Electricity production(% of total) in Kazakhstan in 2000 to that in 2001?
Offer a very short reply. 1.23. What is the ratio of the Electricity production(% of total) of Myanmar in 2000 to that in 2001?
Ensure brevity in your answer.  1.19. What is the ratio of the Electricity production(% of total) of Poland in 2000 to that in 2001?
Your answer should be compact. 0.8. What is the ratio of the Electricity production(% of total) in Jordan in 2000 to that in 2002?
Give a very brief answer. 0.98. What is the ratio of the Electricity production(% of total) of Kazakhstan in 2000 to that in 2002?
Provide a succinct answer. 0.98. What is the ratio of the Electricity production(% of total) of Myanmar in 2000 to that in 2002?
Your answer should be very brief. 23.59. What is the ratio of the Electricity production(% of total) of Poland in 2000 to that in 2002?
Keep it short and to the point. 0.8. What is the ratio of the Electricity production(% of total) in Jordan in 2000 to that in 2003?
Offer a terse response. 0.99. What is the ratio of the Electricity production(% of total) in Kazakhstan in 2000 to that in 2003?
Ensure brevity in your answer.  1.28. What is the ratio of the Electricity production(% of total) in Myanmar in 2000 to that in 2003?
Provide a succinct answer. 23.63. What is the ratio of the Electricity production(% of total) of Poland in 2000 to that in 2003?
Keep it short and to the point. 0.82. What is the ratio of the Electricity production(% of total) in Jordan in 2000 to that in 2004?
Provide a short and direct response. 1.82. What is the ratio of the Electricity production(% of total) of Kazakhstan in 2000 to that in 2004?
Offer a very short reply. 2.95. What is the ratio of the Electricity production(% of total) of Myanmar in 2000 to that in 2004?
Your answer should be compact. 22.95. What is the ratio of the Electricity production(% of total) in Poland in 2000 to that in 2004?
Offer a very short reply. 0.81. What is the ratio of the Electricity production(% of total) in Jordan in 2000 to that in 2005?
Provide a succinct answer. 2.01. What is the ratio of the Electricity production(% of total) of Kazakhstan in 2000 to that in 2005?
Provide a short and direct response. 1.42. What is the ratio of the Electricity production(% of total) of Myanmar in 2000 to that in 2005?
Ensure brevity in your answer.  23.89. What is the ratio of the Electricity production(% of total) of Poland in 2000 to that in 2005?
Make the answer very short. 0.75. What is the ratio of the Electricity production(% of total) in Jordan in 2000 to that in 2006?
Offer a terse response. 3.05. What is the ratio of the Electricity production(% of total) in Kazakhstan in 2000 to that in 2006?
Provide a succinct answer. 1.46. What is the ratio of the Electricity production(% of total) in Myanmar in 2000 to that in 2006?
Your answer should be very brief. 29.72. What is the ratio of the Electricity production(% of total) of Poland in 2000 to that in 2006?
Make the answer very short. 0.74. What is the ratio of the Electricity production(% of total) of Jordan in 2000 to that in 2007?
Make the answer very short. 5.25. What is the ratio of the Electricity production(% of total) in Kazakhstan in 2000 to that in 2007?
Give a very brief answer. 1.52. What is the ratio of the Electricity production(% of total) in Myanmar in 2000 to that in 2007?
Keep it short and to the point. 25.41. What is the ratio of the Electricity production(% of total) in Poland in 2000 to that in 2007?
Your answer should be very brief. 0.76. What is the ratio of the Electricity production(% of total) of Jordan in 2001 to that in 2002?
Keep it short and to the point. 0.98. What is the ratio of the Electricity production(% of total) of Kazakhstan in 2001 to that in 2002?
Your answer should be very brief. 0.8. What is the ratio of the Electricity production(% of total) of Myanmar in 2001 to that in 2002?
Keep it short and to the point. 19.83. What is the ratio of the Electricity production(% of total) of Jordan in 2001 to that in 2003?
Offer a terse response. 0.99. What is the ratio of the Electricity production(% of total) in Kazakhstan in 2001 to that in 2003?
Provide a short and direct response. 1.04. What is the ratio of the Electricity production(% of total) of Myanmar in 2001 to that in 2003?
Provide a short and direct response. 19.86. What is the ratio of the Electricity production(% of total) of Poland in 2001 to that in 2003?
Give a very brief answer. 1.02. What is the ratio of the Electricity production(% of total) in Jordan in 2001 to that in 2004?
Your response must be concise. 1.81. What is the ratio of the Electricity production(% of total) in Kazakhstan in 2001 to that in 2004?
Ensure brevity in your answer.  2.4. What is the ratio of the Electricity production(% of total) in Myanmar in 2001 to that in 2004?
Make the answer very short. 19.28. What is the ratio of the Electricity production(% of total) of Poland in 2001 to that in 2004?
Your answer should be compact. 1.02. What is the ratio of the Electricity production(% of total) in Jordan in 2001 to that in 2005?
Give a very brief answer. 2.01. What is the ratio of the Electricity production(% of total) in Kazakhstan in 2001 to that in 2005?
Provide a short and direct response. 1.16. What is the ratio of the Electricity production(% of total) in Myanmar in 2001 to that in 2005?
Offer a terse response. 20.08. What is the ratio of the Electricity production(% of total) of Poland in 2001 to that in 2005?
Offer a very short reply. 0.94. What is the ratio of the Electricity production(% of total) in Jordan in 2001 to that in 2006?
Keep it short and to the point. 3.05. What is the ratio of the Electricity production(% of total) in Kazakhstan in 2001 to that in 2006?
Provide a succinct answer. 1.19. What is the ratio of the Electricity production(% of total) of Myanmar in 2001 to that in 2006?
Your answer should be very brief. 24.98. What is the ratio of the Electricity production(% of total) in Poland in 2001 to that in 2006?
Ensure brevity in your answer.  0.92. What is the ratio of the Electricity production(% of total) in Jordan in 2001 to that in 2007?
Provide a short and direct response. 5.24. What is the ratio of the Electricity production(% of total) in Kazakhstan in 2001 to that in 2007?
Your answer should be compact. 1.23. What is the ratio of the Electricity production(% of total) of Myanmar in 2001 to that in 2007?
Provide a short and direct response. 21.35. What is the ratio of the Electricity production(% of total) of Poland in 2001 to that in 2007?
Offer a terse response. 0.95. What is the ratio of the Electricity production(% of total) in Jordan in 2002 to that in 2003?
Give a very brief answer. 1.01. What is the ratio of the Electricity production(% of total) of Kazakhstan in 2002 to that in 2003?
Keep it short and to the point. 1.3. What is the ratio of the Electricity production(% of total) in Poland in 2002 to that in 2003?
Make the answer very short. 1.02. What is the ratio of the Electricity production(% of total) of Jordan in 2002 to that in 2004?
Ensure brevity in your answer.  1.85. What is the ratio of the Electricity production(% of total) in Kazakhstan in 2002 to that in 2004?
Make the answer very short. 3. What is the ratio of the Electricity production(% of total) of Myanmar in 2002 to that in 2004?
Provide a succinct answer. 0.97. What is the ratio of the Electricity production(% of total) of Poland in 2002 to that in 2004?
Your response must be concise. 1.01. What is the ratio of the Electricity production(% of total) of Jordan in 2002 to that in 2005?
Keep it short and to the point. 2.04. What is the ratio of the Electricity production(% of total) in Kazakhstan in 2002 to that in 2005?
Keep it short and to the point. 1.44. What is the ratio of the Electricity production(% of total) in Myanmar in 2002 to that in 2005?
Your answer should be very brief. 1.01. What is the ratio of the Electricity production(% of total) in Poland in 2002 to that in 2005?
Provide a succinct answer. 0.94. What is the ratio of the Electricity production(% of total) in Jordan in 2002 to that in 2006?
Provide a short and direct response. 3.11. What is the ratio of the Electricity production(% of total) of Kazakhstan in 2002 to that in 2006?
Your answer should be compact. 1.48. What is the ratio of the Electricity production(% of total) of Myanmar in 2002 to that in 2006?
Give a very brief answer. 1.26. What is the ratio of the Electricity production(% of total) in Poland in 2002 to that in 2006?
Offer a very short reply. 0.92. What is the ratio of the Electricity production(% of total) of Jordan in 2002 to that in 2007?
Make the answer very short. 5.34. What is the ratio of the Electricity production(% of total) of Kazakhstan in 2002 to that in 2007?
Your answer should be very brief. 1.54. What is the ratio of the Electricity production(% of total) in Jordan in 2003 to that in 2004?
Ensure brevity in your answer.  1.83. What is the ratio of the Electricity production(% of total) in Kazakhstan in 2003 to that in 2004?
Keep it short and to the point. 2.31. What is the ratio of the Electricity production(% of total) of Myanmar in 2003 to that in 2004?
Make the answer very short. 0.97. What is the ratio of the Electricity production(% of total) of Jordan in 2003 to that in 2005?
Provide a succinct answer. 2.03. What is the ratio of the Electricity production(% of total) in Kazakhstan in 2003 to that in 2005?
Keep it short and to the point. 1.11. What is the ratio of the Electricity production(% of total) of Myanmar in 2003 to that in 2005?
Your answer should be compact. 1.01. What is the ratio of the Electricity production(% of total) of Poland in 2003 to that in 2005?
Offer a very short reply. 0.92. What is the ratio of the Electricity production(% of total) in Jordan in 2003 to that in 2006?
Offer a terse response. 3.08. What is the ratio of the Electricity production(% of total) in Kazakhstan in 2003 to that in 2006?
Offer a terse response. 1.14. What is the ratio of the Electricity production(% of total) of Myanmar in 2003 to that in 2006?
Keep it short and to the point. 1.26. What is the ratio of the Electricity production(% of total) in Poland in 2003 to that in 2006?
Keep it short and to the point. 0.9. What is the ratio of the Electricity production(% of total) in Jordan in 2003 to that in 2007?
Your answer should be compact. 5.29. What is the ratio of the Electricity production(% of total) in Kazakhstan in 2003 to that in 2007?
Give a very brief answer. 1.19. What is the ratio of the Electricity production(% of total) of Myanmar in 2003 to that in 2007?
Offer a terse response. 1.08. What is the ratio of the Electricity production(% of total) of Poland in 2003 to that in 2007?
Your response must be concise. 0.93. What is the ratio of the Electricity production(% of total) in Jordan in 2004 to that in 2005?
Keep it short and to the point. 1.11. What is the ratio of the Electricity production(% of total) in Kazakhstan in 2004 to that in 2005?
Provide a succinct answer. 0.48. What is the ratio of the Electricity production(% of total) in Myanmar in 2004 to that in 2005?
Give a very brief answer. 1.04. What is the ratio of the Electricity production(% of total) in Poland in 2004 to that in 2005?
Offer a terse response. 0.93. What is the ratio of the Electricity production(% of total) in Jordan in 2004 to that in 2006?
Offer a terse response. 1.68. What is the ratio of the Electricity production(% of total) of Kazakhstan in 2004 to that in 2006?
Provide a short and direct response. 0.49. What is the ratio of the Electricity production(% of total) of Myanmar in 2004 to that in 2006?
Offer a terse response. 1.3. What is the ratio of the Electricity production(% of total) of Poland in 2004 to that in 2006?
Your answer should be very brief. 0.91. What is the ratio of the Electricity production(% of total) in Jordan in 2004 to that in 2007?
Provide a succinct answer. 2.89. What is the ratio of the Electricity production(% of total) of Kazakhstan in 2004 to that in 2007?
Make the answer very short. 0.51. What is the ratio of the Electricity production(% of total) of Myanmar in 2004 to that in 2007?
Give a very brief answer. 1.11. What is the ratio of the Electricity production(% of total) in Poland in 2004 to that in 2007?
Keep it short and to the point. 0.93. What is the ratio of the Electricity production(% of total) of Jordan in 2005 to that in 2006?
Provide a short and direct response. 1.52. What is the ratio of the Electricity production(% of total) in Kazakhstan in 2005 to that in 2006?
Keep it short and to the point. 1.03. What is the ratio of the Electricity production(% of total) of Myanmar in 2005 to that in 2006?
Make the answer very short. 1.24. What is the ratio of the Electricity production(% of total) in Poland in 2005 to that in 2006?
Your response must be concise. 0.98. What is the ratio of the Electricity production(% of total) in Jordan in 2005 to that in 2007?
Provide a short and direct response. 2.61. What is the ratio of the Electricity production(% of total) in Kazakhstan in 2005 to that in 2007?
Ensure brevity in your answer.  1.07. What is the ratio of the Electricity production(% of total) of Myanmar in 2005 to that in 2007?
Give a very brief answer. 1.06. What is the ratio of the Electricity production(% of total) in Poland in 2005 to that in 2007?
Provide a short and direct response. 1.01. What is the ratio of the Electricity production(% of total) of Jordan in 2006 to that in 2007?
Offer a terse response. 1.72. What is the ratio of the Electricity production(% of total) in Kazakhstan in 2006 to that in 2007?
Your answer should be very brief. 1.04. What is the ratio of the Electricity production(% of total) in Myanmar in 2006 to that in 2007?
Your response must be concise. 0.85. What is the ratio of the Electricity production(% of total) of Poland in 2006 to that in 2007?
Your answer should be compact. 1.03. What is the difference between the highest and the second highest Electricity production(% of total) of Jordan?
Ensure brevity in your answer.  0.85. What is the difference between the highest and the second highest Electricity production(% of total) in Kazakhstan?
Your response must be concise. 0.08. What is the difference between the highest and the second highest Electricity production(% of total) of Myanmar?
Give a very brief answer. 2.16. What is the difference between the highest and the second highest Electricity production(% of total) of Poland?
Offer a very short reply. 0.03. What is the difference between the highest and the lowest Electricity production(% of total) in Jordan?
Offer a terse response. 73.87. What is the difference between the highest and the lowest Electricity production(% of total) in Kazakhstan?
Ensure brevity in your answer.  3.49. What is the difference between the highest and the lowest Electricity production(% of total) of Myanmar?
Give a very brief answer. 13.05. What is the difference between the highest and the lowest Electricity production(% of total) in Poland?
Make the answer very short. 0.47. 